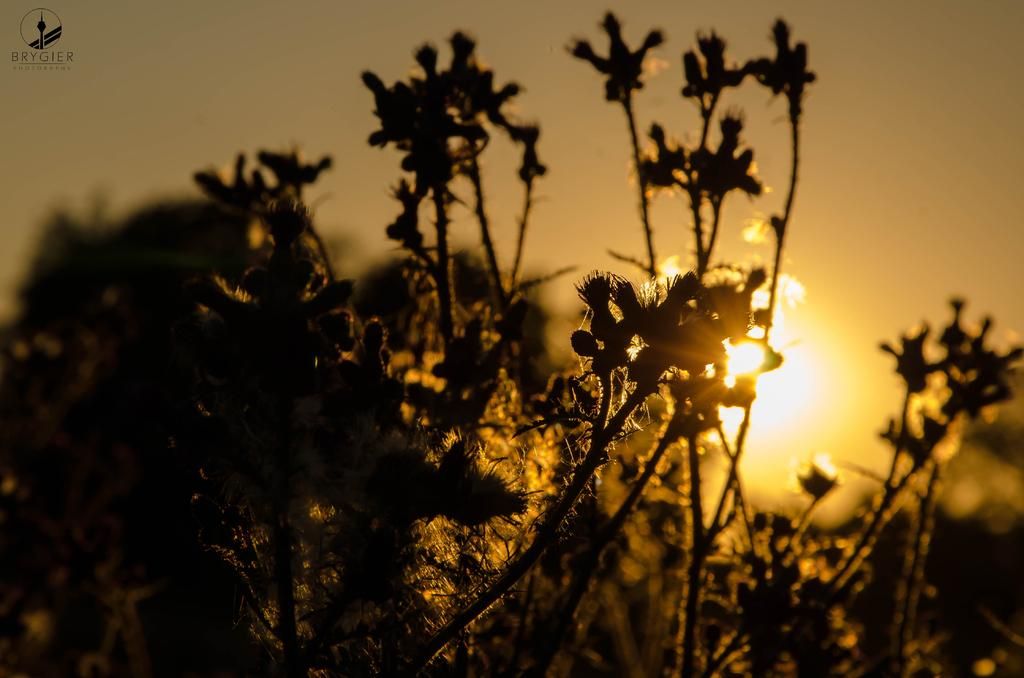What celestial bodies are depicted in the image? There are planets in the image. Which of the celestial bodies is specifically mentioned in the image? The moon is visible in the image. What background is present in the image? The sky is present in the image. How would you describe the lighting in the image? The image is a little dark. Can you see the person's toes in the image? There are no people or body parts visible in the image; it features celestial bodies and a dark sky. 